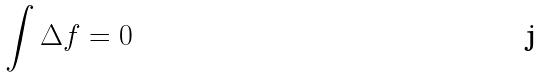Convert formula to latex. <formula><loc_0><loc_0><loc_500><loc_500>\int \Delta f = 0</formula> 